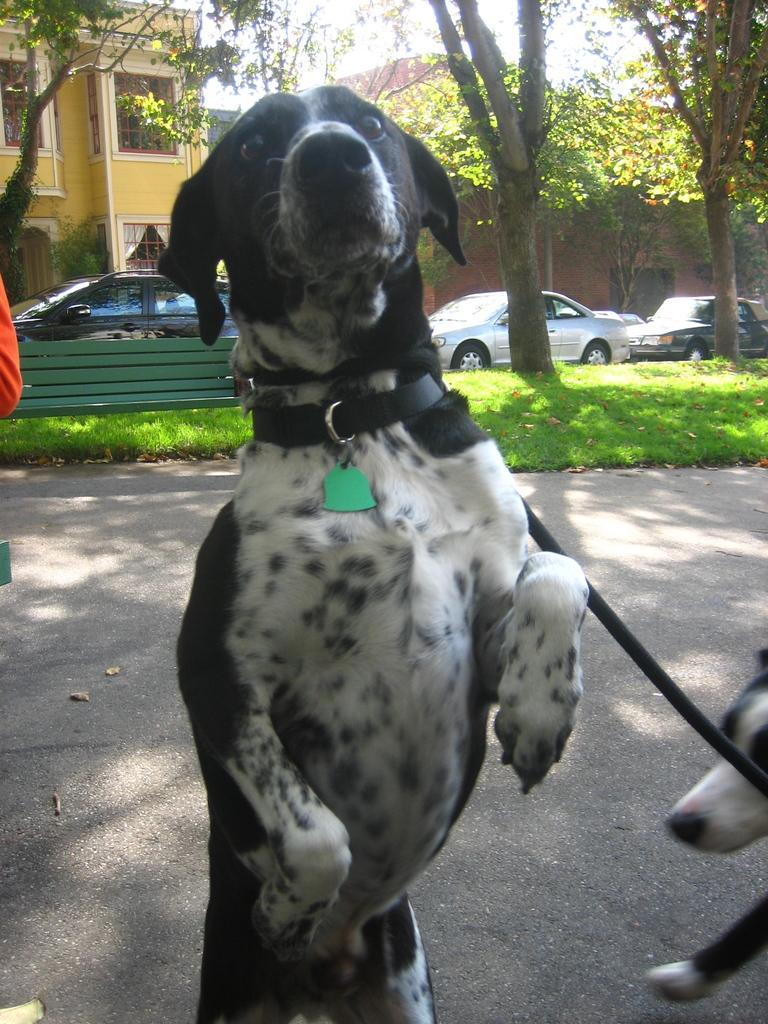What animals are in the foreground of the image? There are dogs in the foreground of the image. Where are the dogs located? The dogs are on the road. What can be seen on the left side of the image? There is a person's hand on the left side of the image. What is in the center of the image? There are cars, trees, a bench, grass, and buildings in the center of the image. What is the weather like in the image? The sky is sunny in the image. Can you tell me how many pairs of jeans are visible in the image? There are no jeans present in the image. What type of exercise are the dogs performing in the image? The dogs are not performing any exercise in the image; they are simply on the road. 